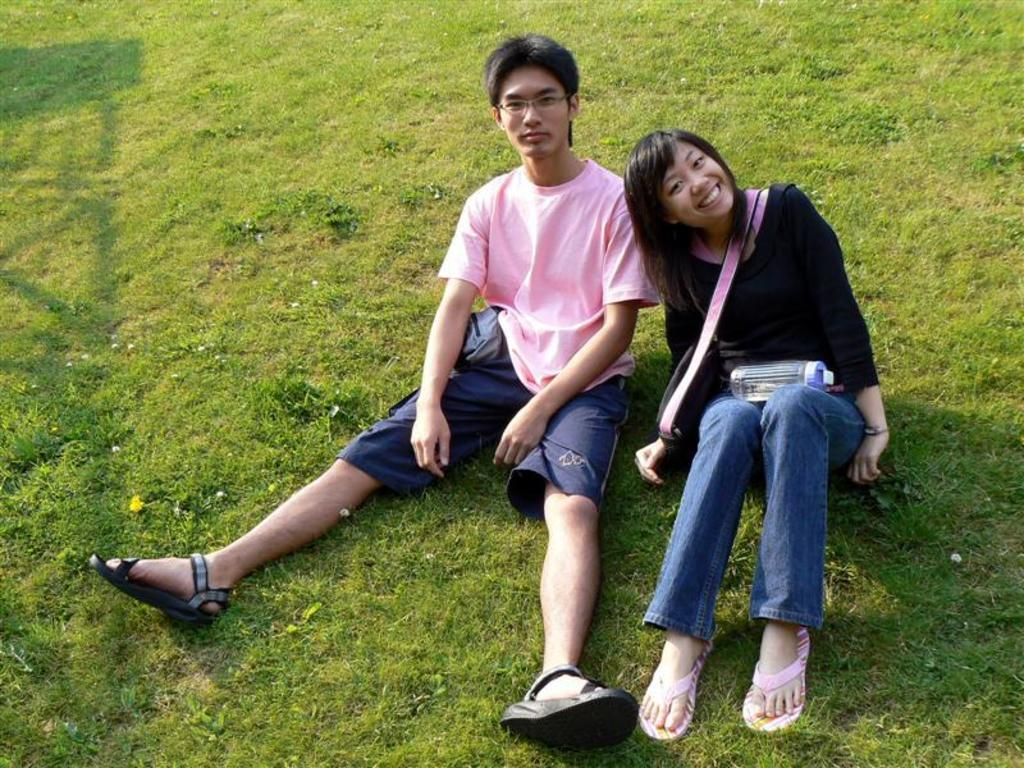Who is present in the image? There is a man and a girl in the image. What are the man and girl doing in the image? The man and girl are sitting on the grass. What objects can be seen in the image besides the man and girl? There is a bottle and a bag in the image. What type of competition is taking place in the image? There is no competition present in the image; it simply shows a man and a girl sitting on the grass with a bottle and a bag. 